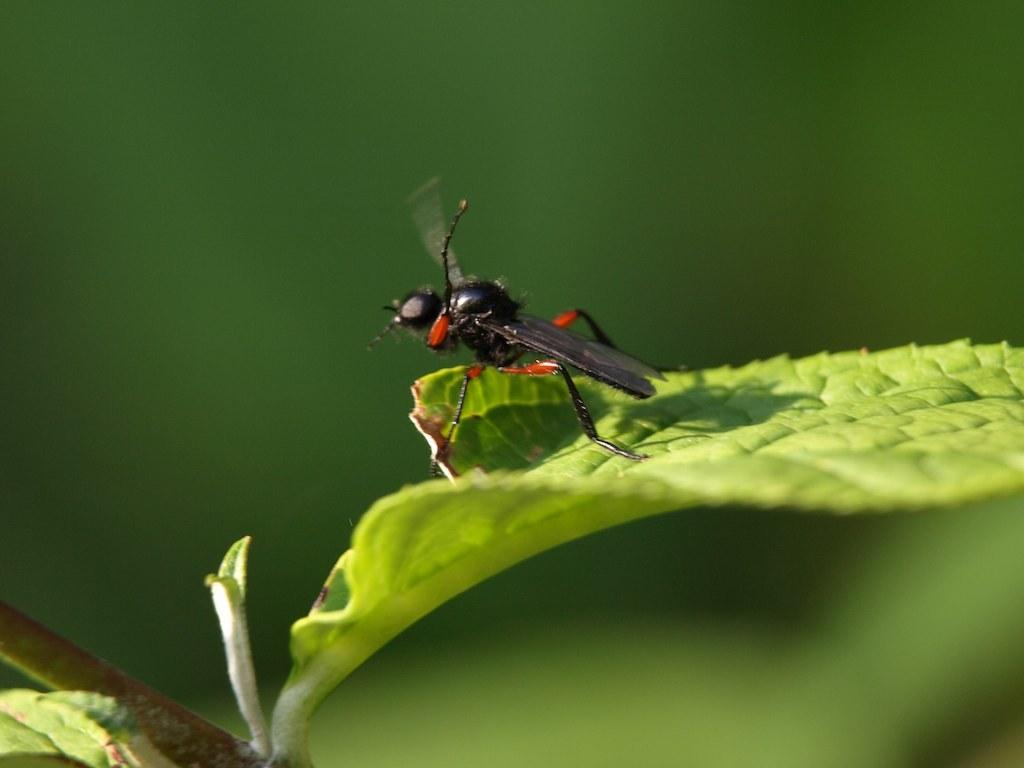What is present in the image? There is a fly in the image. Where is the fly located? The fly is standing on a leaf. What is the leaf from? The leaf is from a plant. What is the color of the background in the image? The background of the image is green in color. How many mines are visible in the image? There are no mines present in the image; it features a fly on a leaf from a plant. What is the amount of week shown in the image? The concept of "week" is not applicable to the image, as it features a fly on a leaf from a plant. 